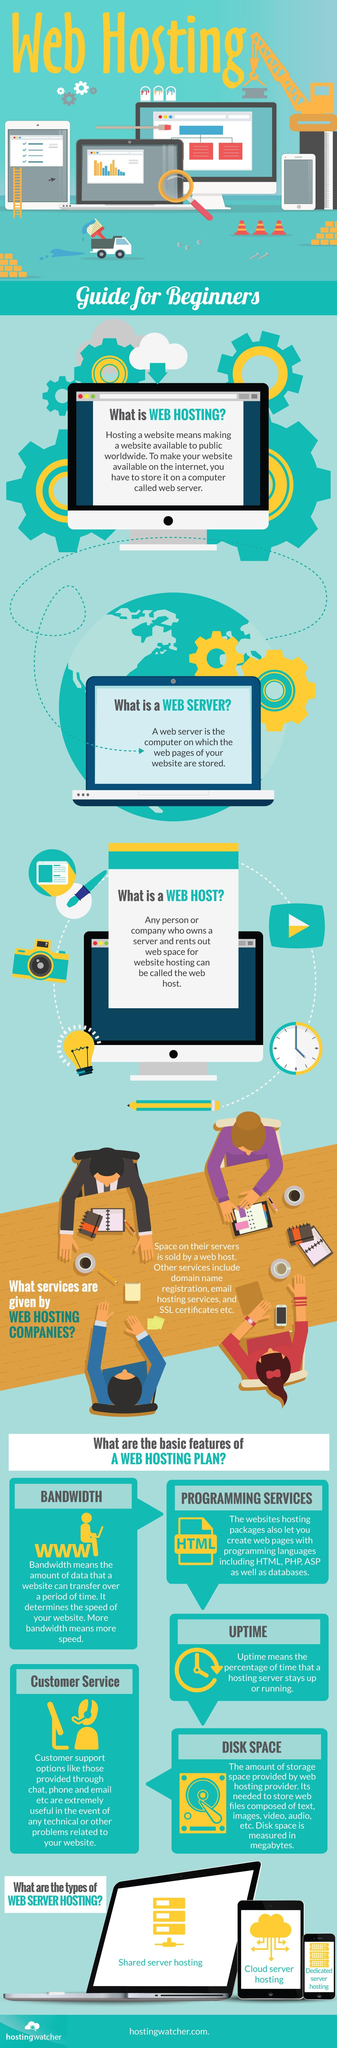Draw attention to some important aspects in this diagram. On a tablet screen, the type of web hosting shown is cloud server hosting. There are three types of server hosting shown. In the event of technical failure, the useful feature of web hosting services for customers is customer support options. 